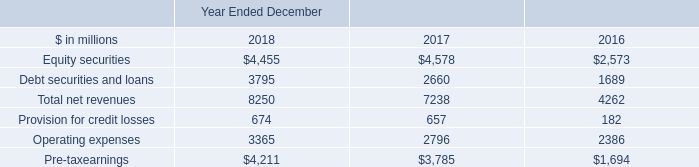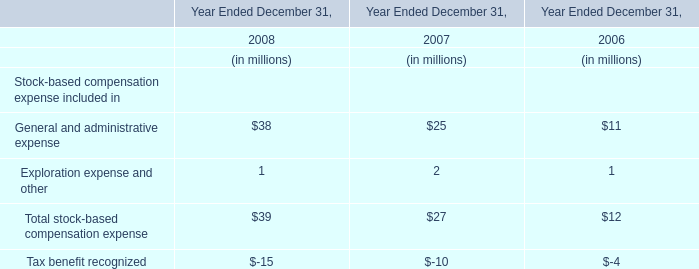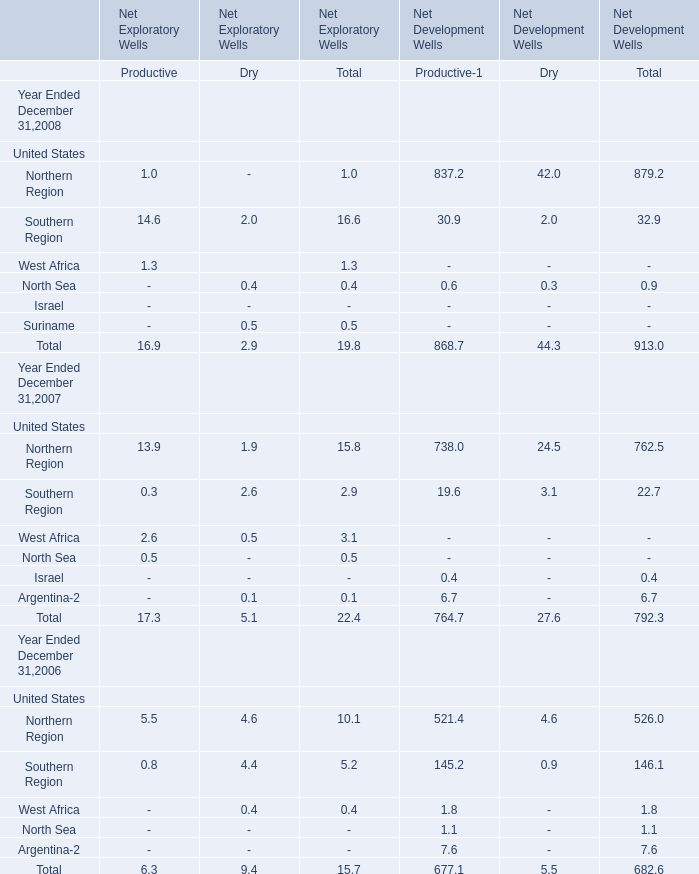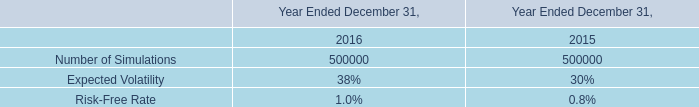What is the total value of Northern Region, Southern Region, West Africa and North Sea for Productive of Net Exploratory Wells in 2007? 
Computations: (((13.9 + 0.3) + 2.6) + 0.5)
Answer: 17.3. 